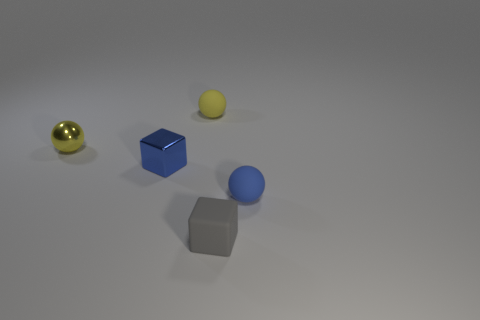Is the material of the object that is right of the gray block the same as the tiny blue thing that is left of the small blue matte ball?
Your answer should be very brief. No. Is the number of small gray matte objects in front of the gray cube less than the number of red matte cylinders?
Ensure brevity in your answer.  No. There is a rubber cube that is on the right side of the tiny blue cube; what color is it?
Your answer should be very brief. Gray. What is the blue block in front of the small yellow thing that is to the right of the small yellow metal thing made of?
Your answer should be compact. Metal. Is there a red matte cylinder of the same size as the blue shiny thing?
Your response must be concise. No. How many objects are either small blocks that are in front of the small blue ball or small cubes that are to the right of the yellow matte sphere?
Your answer should be very brief. 1. Does the cube that is in front of the blue ball have the same size as the matte thing that is on the left side of the rubber block?
Ensure brevity in your answer.  Yes. There is a thing behind the yellow shiny thing; is there a tiny shiny object that is behind it?
Your answer should be very brief. No. There is a tiny yellow matte ball; how many tiny metal balls are behind it?
Your answer should be very brief. 0. What number of other objects are the same color as the small matte cube?
Your response must be concise. 0. 